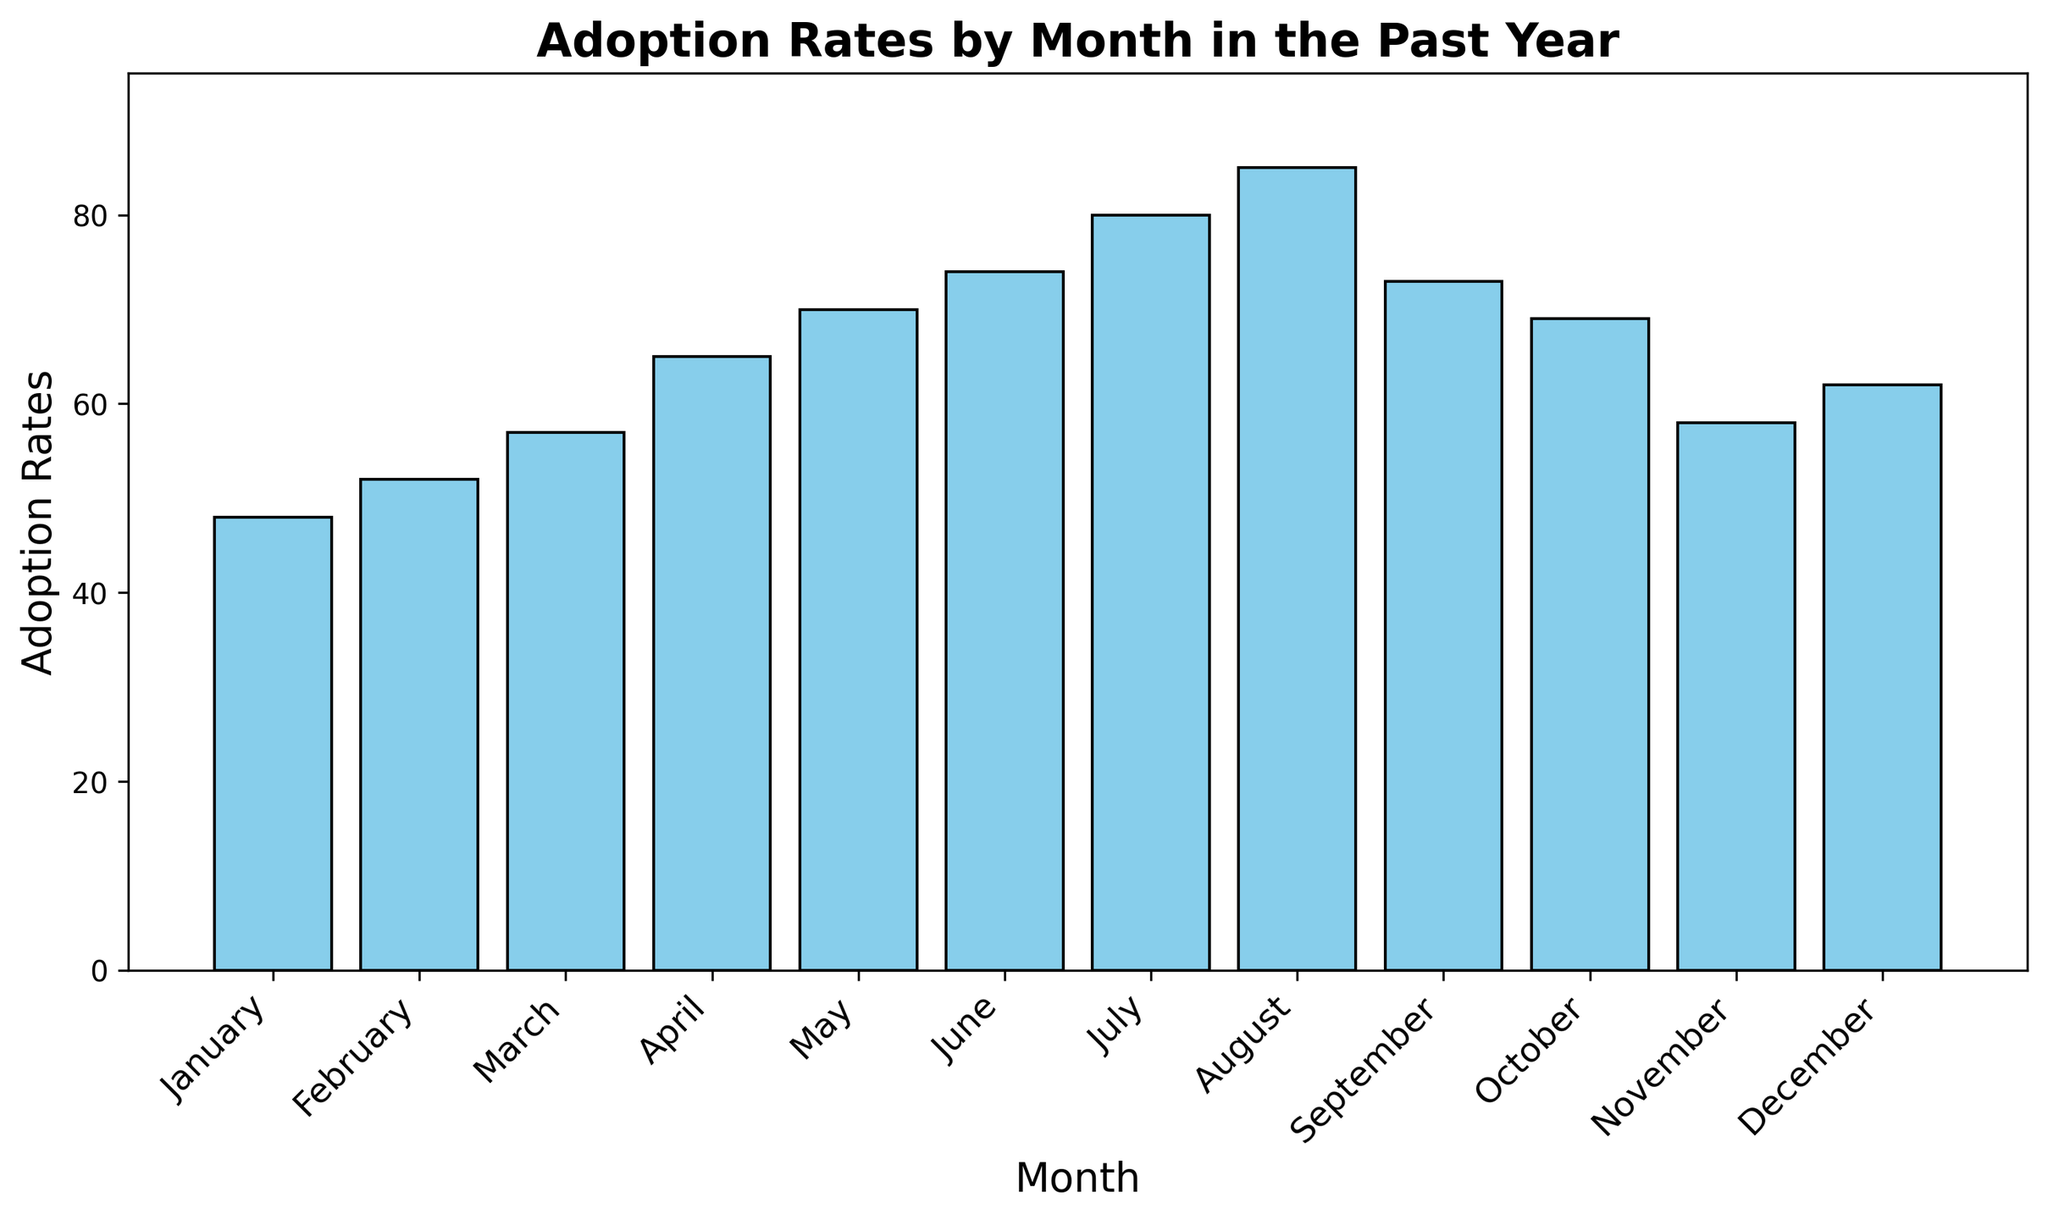what's the range of the adoption rates across the months? To find the range, subtract the smallest value from the largest value. The highest adoption rate is 85 and the lowest is 48, so the range is 85 - 48.
Answer: 37 which month had the highest adoption rate? The bar representing August is the tallest, indicating that August had the highest adoption rate.
Answer: August compare the adoption rates between January and June. Which month had a higher rate? Looking at the heights of the bars, June's bar is taller than January's. June had an adoption rate of 74 while January had a rate of 48.
Answer: June in which month did the adoption rate first exceed 70? The bar for May is the first one where the adoption height exceeds 70.
Answer: May how does the adoption rate in September compare to that in December? The height of the bar for September is higher than December. September had an adoption rate of 73 and December had 62.
Answer: September what's the difference in adoption rates between March and November? The bar for March has a height of 57 and November's bar is 58. The difference is 58 - 57.
Answer: 1 what's the total adoption rate for the first quarter (January-March)? Sum the adoption rates for January, February, and March: 48 + 52 + 57. The total is 157.
Answer: 157 what's the average adoption rate for the summer months (June-August)? Add the adoption rates for June, July, and August: 74 + 80 + 85, and divide by 3. The sum is 239, so the average is 239 / 3 which is approximately 79.67.
Answer: 79.67 how many months had adoption rates greater than 60? February, March, April, May, June, July, August, September, October, and December all had adoption rates greater than 60. Count these months.
Answer: 10 which month had the lowest adoption rate? The bar representing January is the shortest, indicating that January had the lowest adoption rate.
Answer: January 